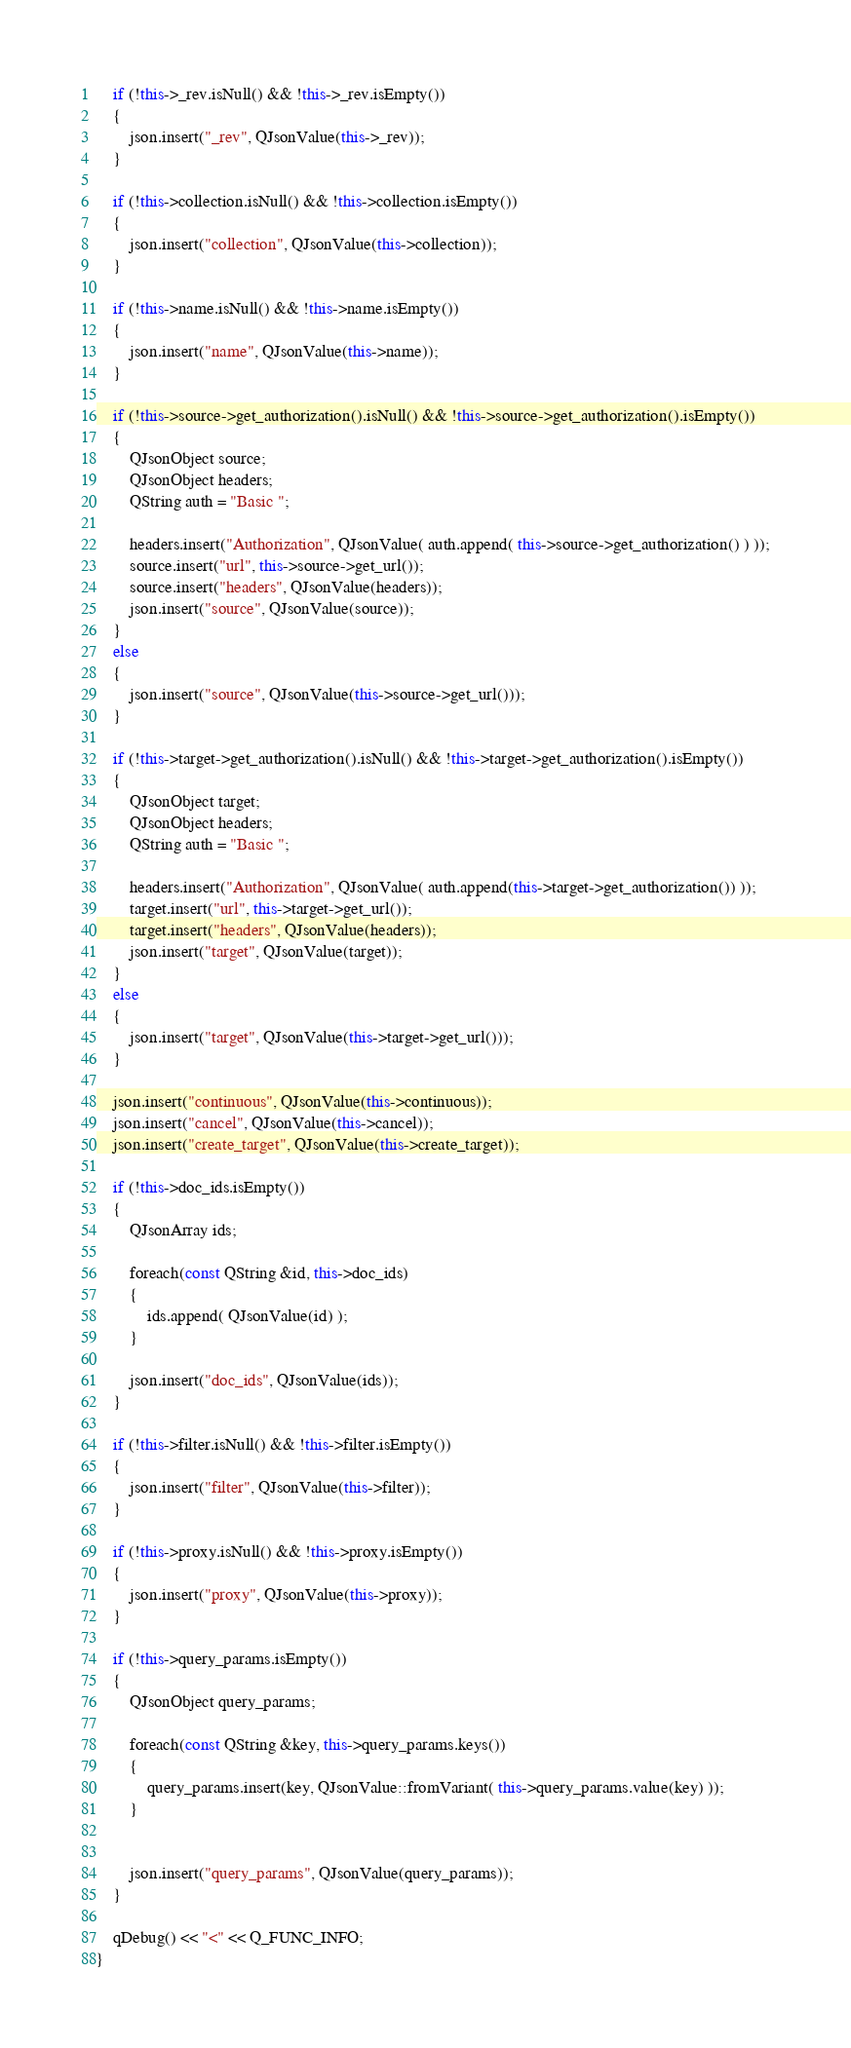Convert code to text. <code><loc_0><loc_0><loc_500><loc_500><_C++_>
    if (!this->_rev.isNull() && !this->_rev.isEmpty())
    {
        json.insert("_rev", QJsonValue(this->_rev));
    }

    if (!this->collection.isNull() && !this->collection.isEmpty())
    {
        json.insert("collection", QJsonValue(this->collection));
    }

    if (!this->name.isNull() && !this->name.isEmpty())
    {
        json.insert("name", QJsonValue(this->name));
    }

    if (!this->source->get_authorization().isNull() && !this->source->get_authorization().isEmpty())
    {
        QJsonObject source;
        QJsonObject headers;
        QString auth = "Basic ";

        headers.insert("Authorization", QJsonValue( auth.append( this->source->get_authorization() ) ));
        source.insert("url", this->source->get_url());
        source.insert("headers", QJsonValue(headers));
        json.insert("source", QJsonValue(source));
    }
    else
    {
        json.insert("source", QJsonValue(this->source->get_url()));
    }

    if (!this->target->get_authorization().isNull() && !this->target->get_authorization().isEmpty())
    {
        QJsonObject target;
        QJsonObject headers;
        QString auth = "Basic ";

        headers.insert("Authorization", QJsonValue( auth.append(this->target->get_authorization()) ));
        target.insert("url", this->target->get_url());
        target.insert("headers", QJsonValue(headers));
        json.insert("target", QJsonValue(target));
    }
    else
    {
        json.insert("target", QJsonValue(this->target->get_url()));
    }

    json.insert("continuous", QJsonValue(this->continuous));
    json.insert("cancel", QJsonValue(this->cancel));
    json.insert("create_target", QJsonValue(this->create_target));

    if (!this->doc_ids.isEmpty())
    {
        QJsonArray ids;

        foreach(const QString &id, this->doc_ids)
        {
            ids.append( QJsonValue(id) );
        }

        json.insert("doc_ids", QJsonValue(ids));
    }

    if (!this->filter.isNull() && !this->filter.isEmpty())
    {
        json.insert("filter", QJsonValue(this->filter));
    }

    if (!this->proxy.isNull() && !this->proxy.isEmpty())
    {
        json.insert("proxy", QJsonValue(this->proxy));
    }

    if (!this->query_params.isEmpty())
    {
        QJsonObject query_params;

        foreach(const QString &key, this->query_params.keys())
        {
            query_params.insert(key, QJsonValue::fromVariant( this->query_params.value(key) ));
        }


        json.insert("query_params", QJsonValue(query_params));
    }

    qDebug() << "<" << Q_FUNC_INFO;
}
</code> 